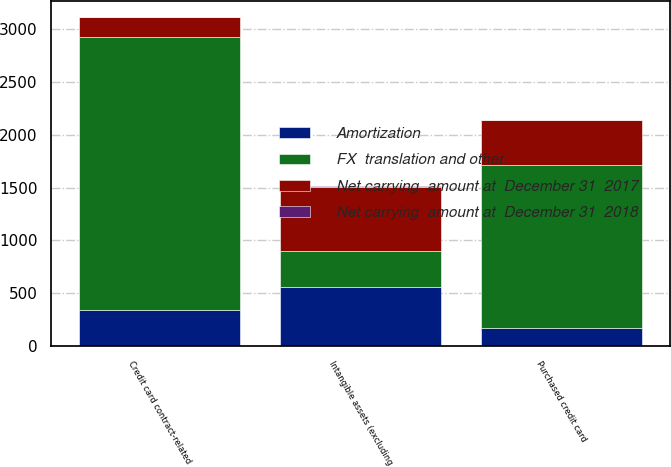Convert chart. <chart><loc_0><loc_0><loc_500><loc_500><stacked_bar_chart><ecel><fcel>Purchased credit card<fcel>Credit card contract-related<fcel>Intangible assets (excluding<nl><fcel>FX  translation and other<fcel>1539<fcel>2589<fcel>339<nl><fcel>Net carrying  amount at  December 31  2017<fcel>429<fcel>185<fcel>614<nl><fcel>Amortization<fcel>173<fcel>339<fcel>557<nl><fcel>Net carrying  amount at  December 31  2018<fcel>2<fcel>1<fcel>9<nl></chart> 